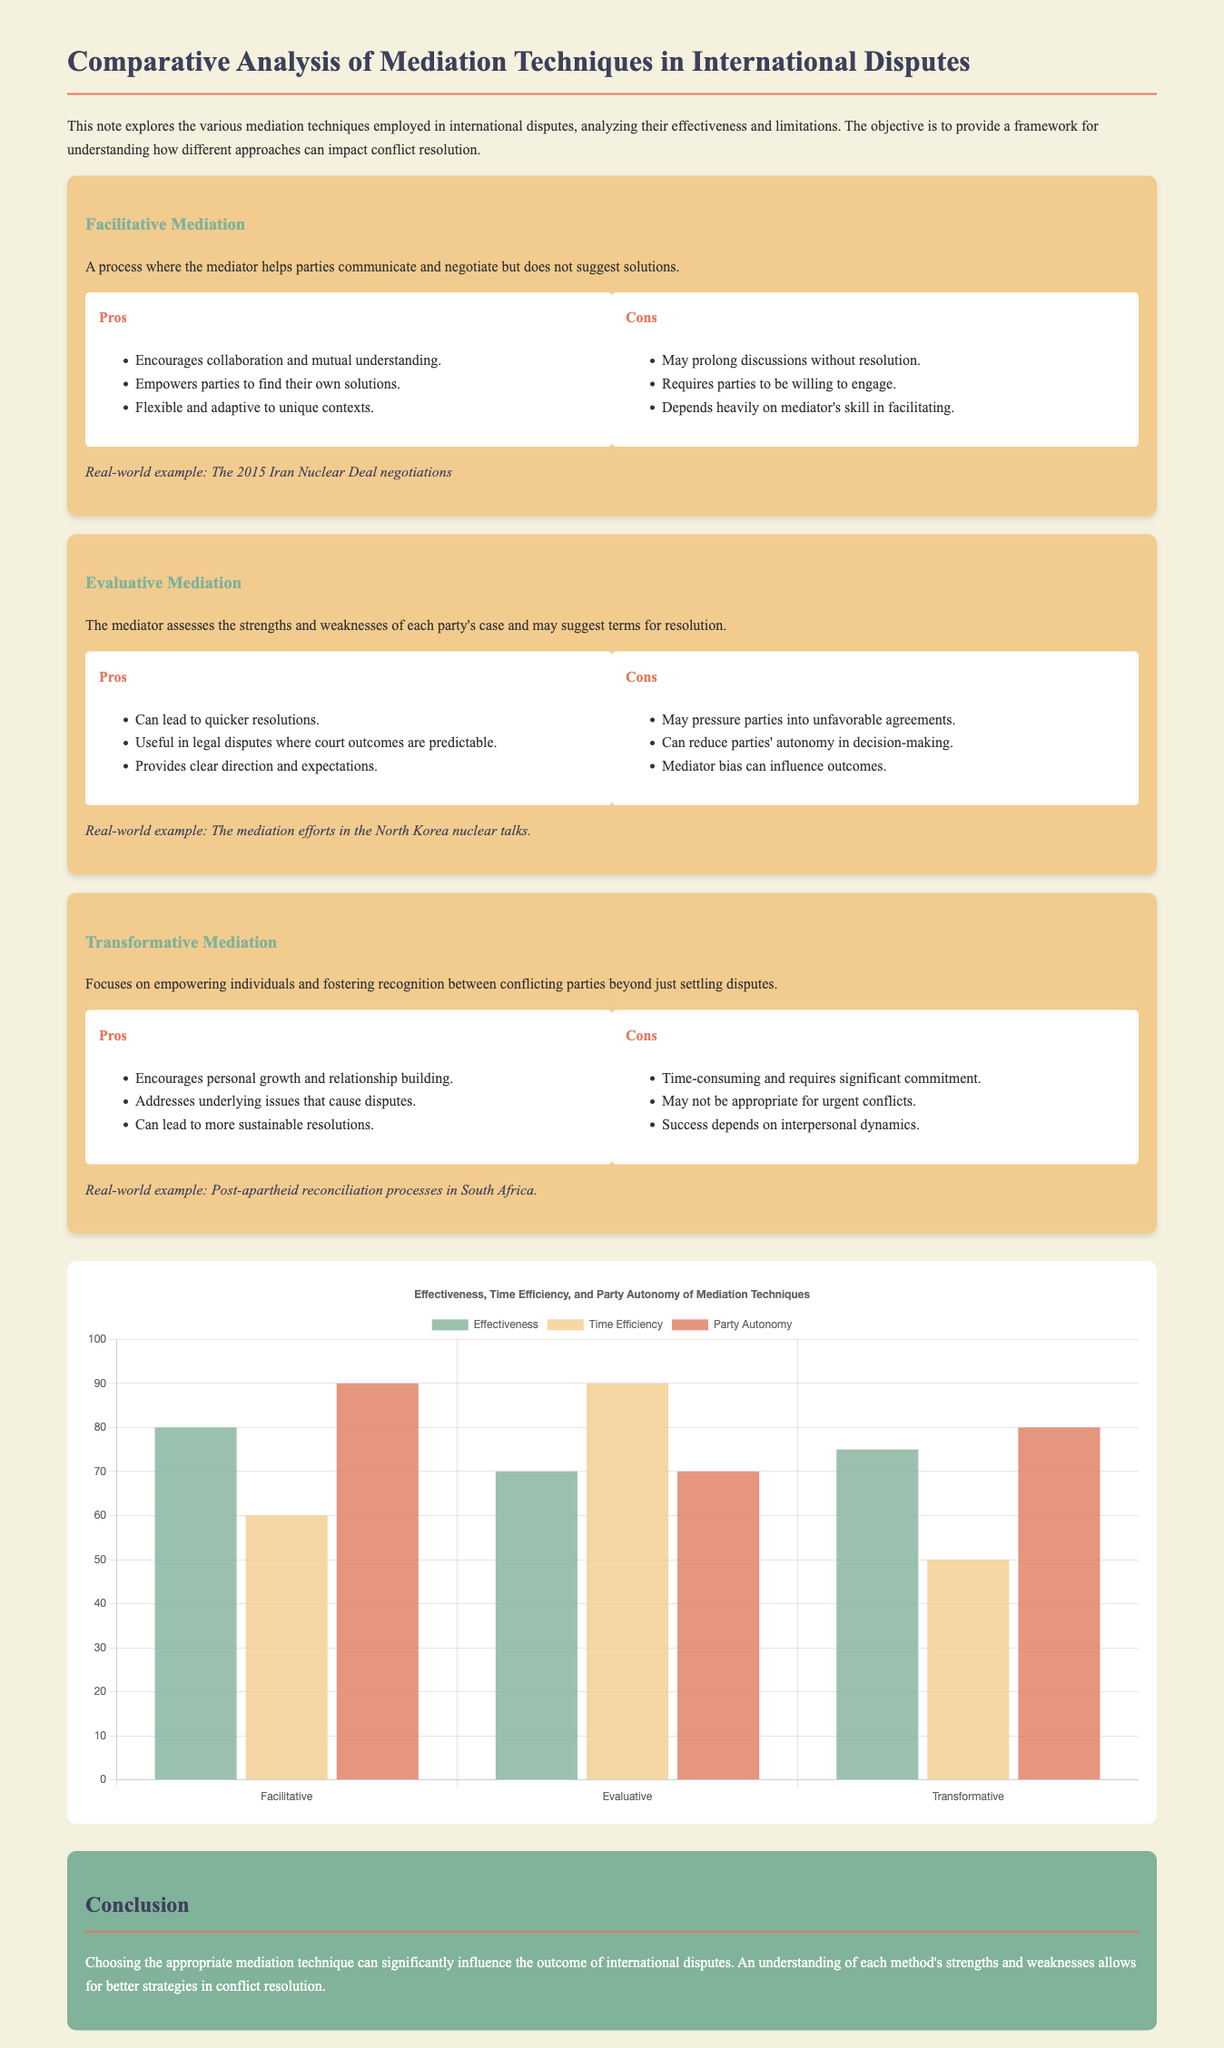What is the title of the document? The title of the document is indicated at the top of the rendered page.
Answer: Comparative Analysis of Mediation Techniques in International Disputes Which mediation technique emphasizes personal growth and relationship building? The document describes transformative mediation as focusing on empowerment and relation building.
Answer: Transformative Mediation What is the effectiveness rating of Evaluative mediation in the chart? The chart displays the effectiveness rating for each mediation technique, with Evaluative Mediation having a rating of 70.
Answer: 70 What are the two advantages of Facilitative Mediation listed in the document? The document lists several pros for Facilitative Mediation, including "Encourages collaboration and mutual understanding" and "Empowers parties to find their own solutions."
Answer: Encourages collaboration and mutual understanding; Empowers parties to find their own solutions Which mediation technique is associated with the 2015 Iran Nuclear Deal negotiations? The document provides a real-world example associated with Facilitative Mediation pertaining to the Iran Nuclear Deal.
Answer: Facilitative Mediation What is the max score on the y-axis of the chart? The maximum value on the y-axis is set to provide a context for evaluating the effectiveness, time efficiency, and party autonomy.
Answer: 100 What color represents Time Efficiency in the chart? The chart differentiates datasets with varying colors, where Time Efficiency data is shown in rgba(242, 204, 143, 0.8).
Answer: rgba(242, 204, 143, 0.8) What real-world example is provided for Transformative Mediation? The document includes the post-apartheid reconciliation processes in South Africa as an example.
Answer: Post-apartheid reconciliation processes in South Africa 